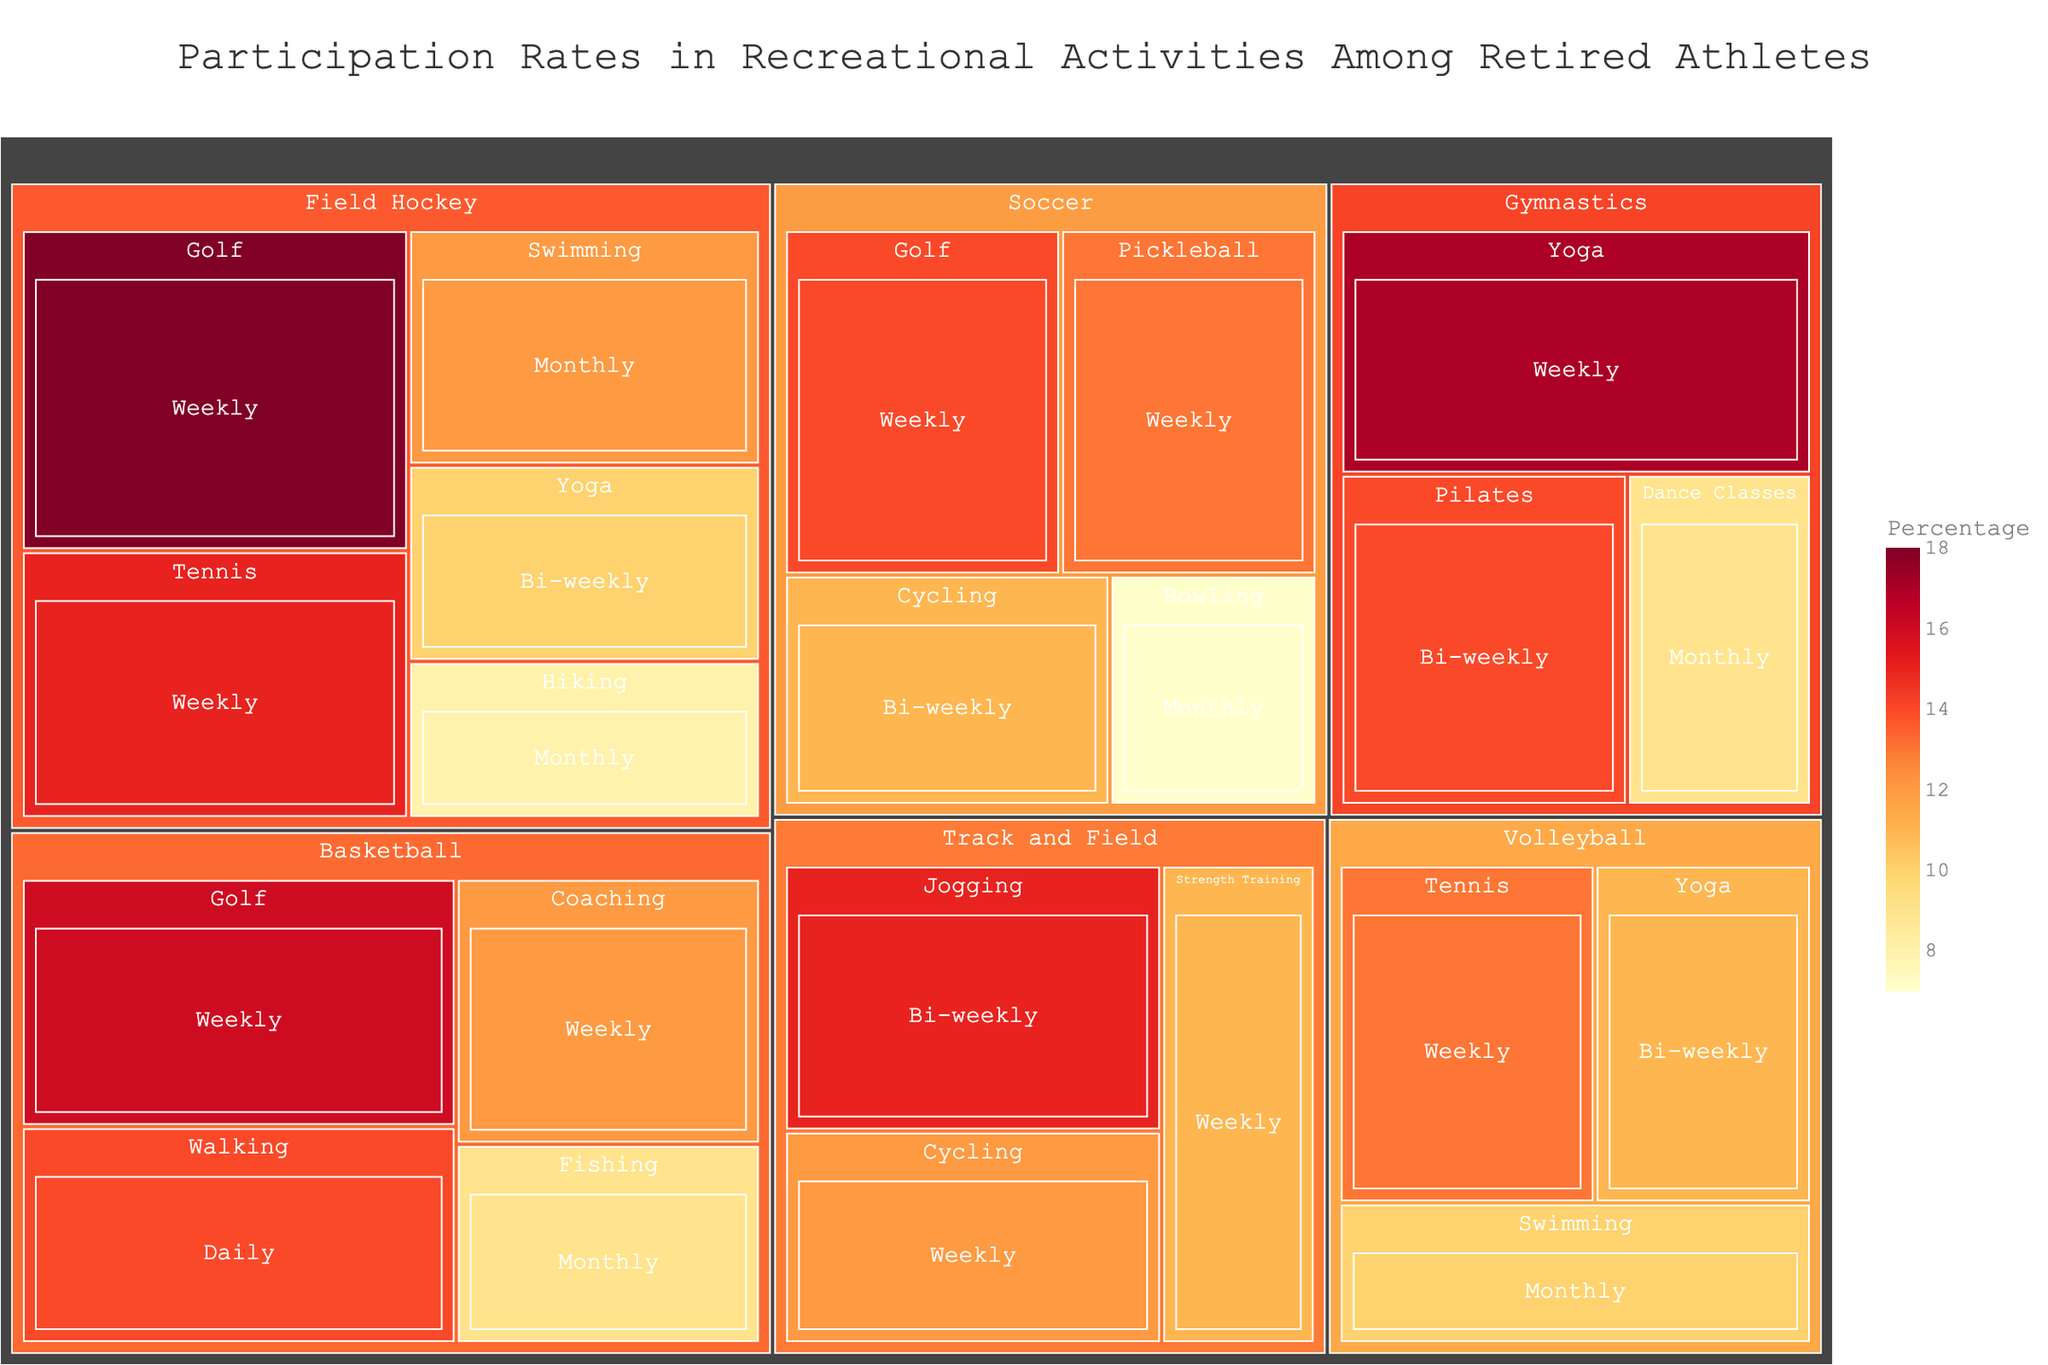What is the title of the treemap? The title is typically found at the top of the treemap and provides a summary of what the figure represents.
Answer: Participation Rates in Recreational Activities Among Retired Athletes Which sport has the highest percentage for Yoga? Look for the Yoga activity in the treemap and compare the percentages within different sports.
Answer: Gymnastics What is the weekly participation rate for Golf across all sports? Identify all occurrences of Golf with a weekly frequency and sum their percentages (Field Hockey: 18% + Soccer: 14% + Basketball: 16%).
Answer: 48% Which sport has the most categories represented in the treemap? Count the number of activities represented within each sport category in the treemap.
Answer: Field Hockey How does the monthly participation rate for Swimming compare between Field Hockey and Volleyball? Locate monthly Swimming activity for both Field Hockey and Volleyball, and compare their values (Field Hockey: 12%, Volleyball: 10%).
Answer: Field Hockey is higher What is the total percentage of bi-weekly activities for Soccer? Sum the percentages of bi-weekly activities within the Soccer category (Cycling: 11%).
Answer: 11% How does the participation rate of weekly Tennis in Field Hockey compare to that in Volleyball? Locate weekly Tennis activity for both Field Hockey and Volleyball, and compare their values (Field Hockey: 15%, Volleyball: 13%).
Answer: Field Hockey is higher What is the average participation rate for weekly activities in Gymnastics? Identify weekly activities in Gymnastics and calculate their average ((Yoga: 17% + Pilates: 14%)/2).
Answer: 15.5% Which two sports have the highest daily participation rates? Look for all activities with a daily frequency and identify the sports they belong to, then compare their percentages.
Answer: Basketball What is the combined percentage for all activities in Track and Field? Sum the percentages for all activities in the Track and Field category (Jogging: 15% + Cycling: 12% + Strength Training: 11%).
Answer: 38% 